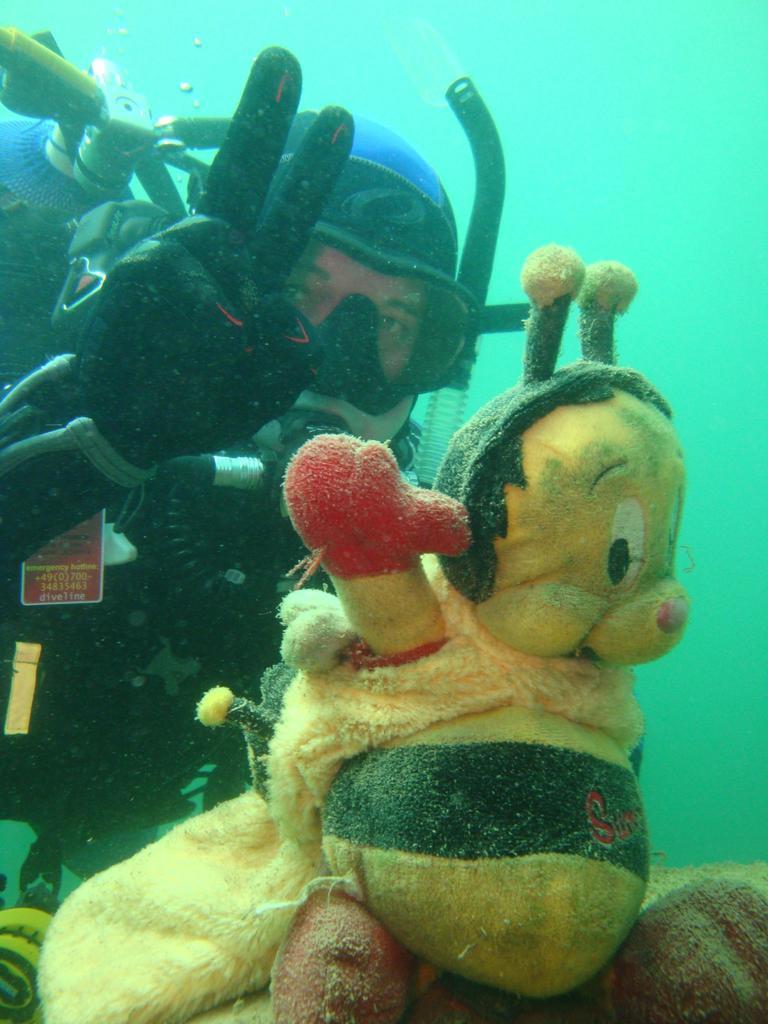Describe this image in one or two sentences. In this image there is a person doing scuba diving under the water, in-front of him there is a doll. 